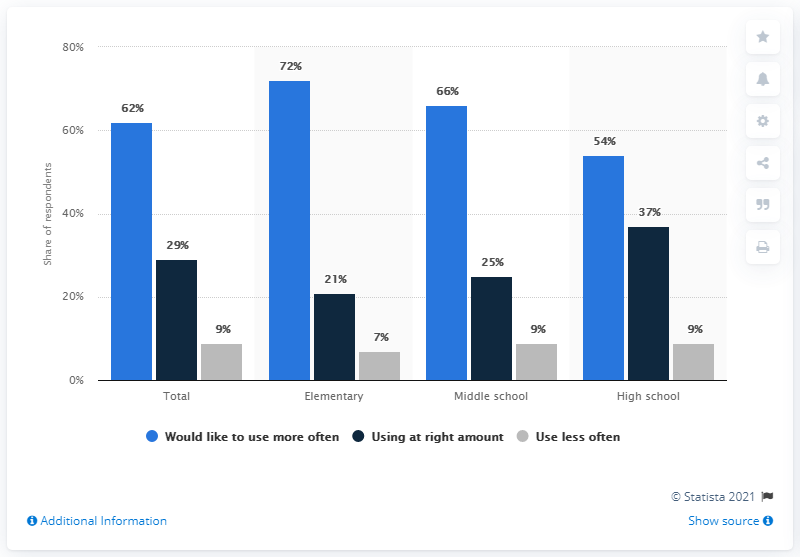Mention a couple of crucial points in this snapshot. The highest dark blue bar has a value of 37. The average of the first and third highest values in the blue bar is 69. 